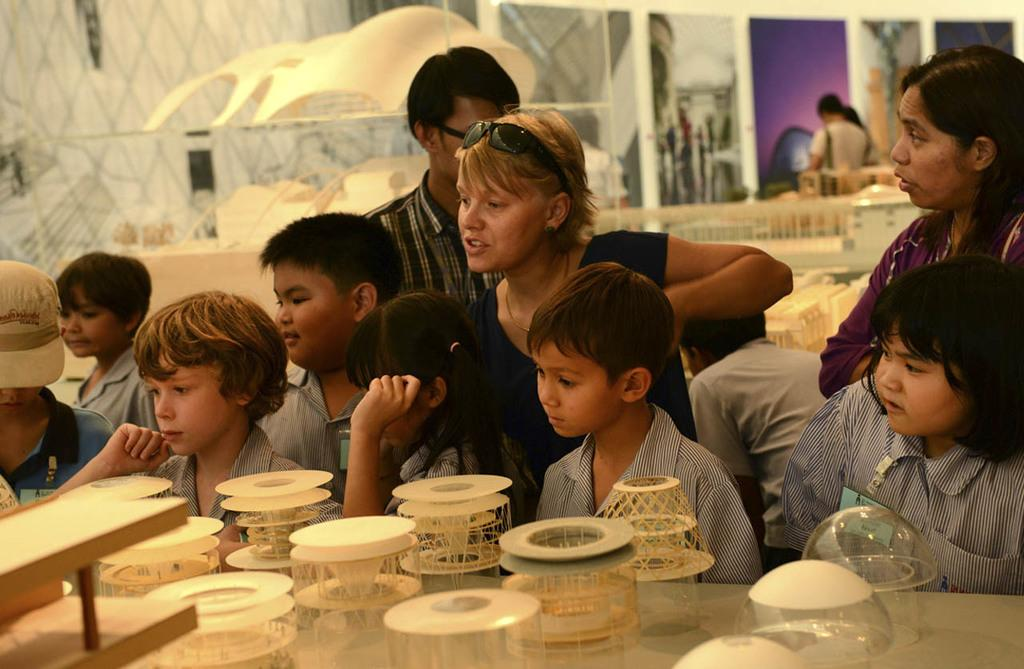What is happening in the image? There are people standing in the image. Can you describe the objects in the image? There is a glass on a table in the image. How many buildings can be seen in the image? There are no buildings visible in the image; it only shows people standing and a glass on a table. What color are the eyes of the zebra in the image? There is no zebra present in the image, so we cannot determine the color of its eyes. 